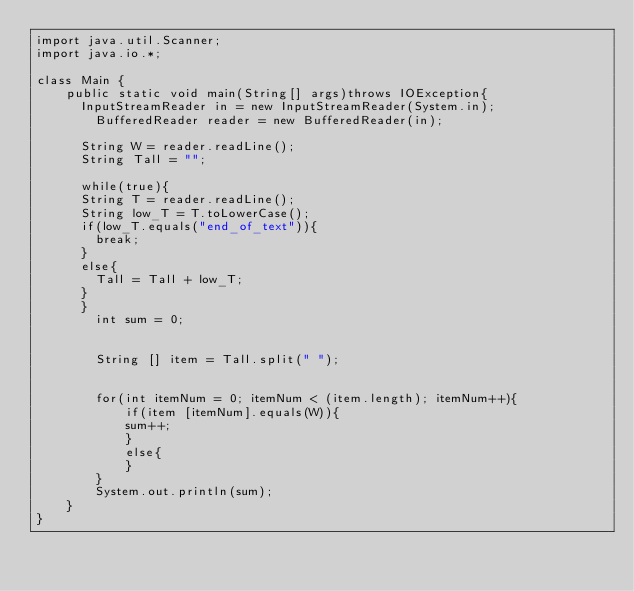<code> <loc_0><loc_0><loc_500><loc_500><_Java_>import java.util.Scanner;
import java.io.*;

class Main {
    public static void main(String[] args)throws IOException{ 
    	InputStreamReader in = new InputStreamReader(System.in);
        BufferedReader reader = new BufferedReader(in);
    	   	                                                 
    	String W = reader.readLine();
    	String Tall = "";
    	
    	while(true){
    	String T = reader.readLine();
    	String low_T = T.toLowerCase();
    	if(low_T.equals("end_of_text")){
    		break;
    	}
    	else{
        Tall = Tall + low_T; 
    	}
    	}
        int sum = 0;
        
        
        String [] item = Tall.split(" ");
        
        
        for(int itemNum = 0; itemNum < (item.length); itemNum++){
            if(item [itemNum].equals(W)){
            sum++;
            }
            else{
            }
        }
        System.out.println(sum);
    }
}</code> 